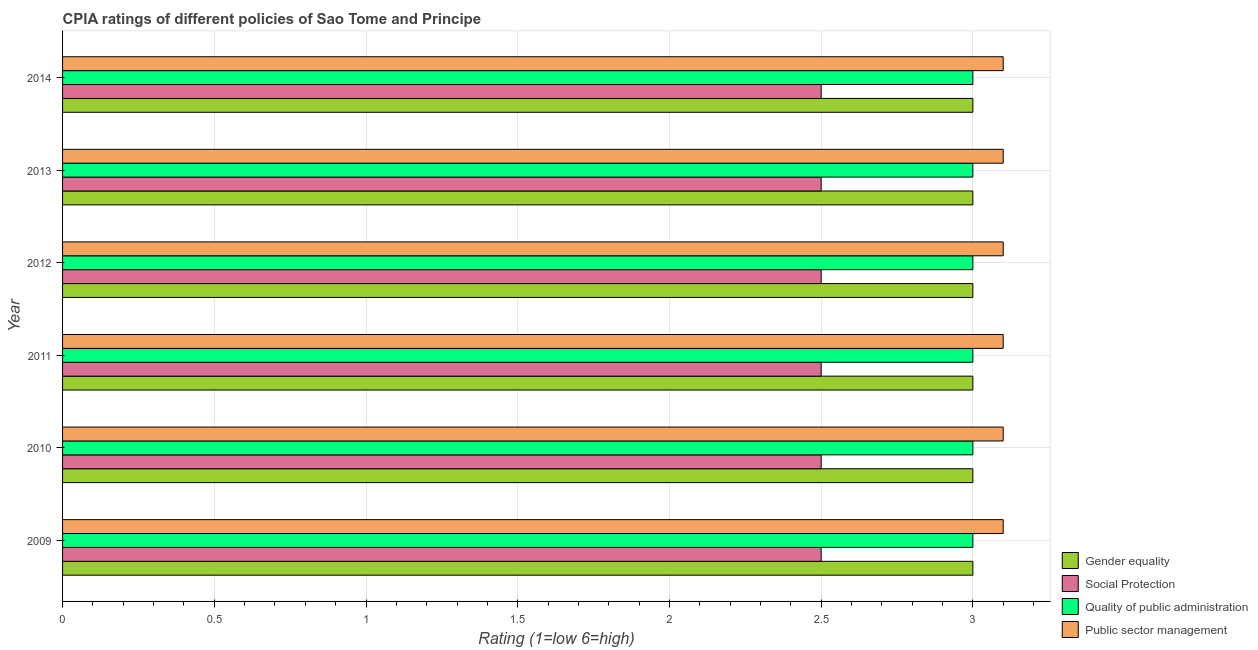How many different coloured bars are there?
Offer a terse response. 4. Are the number of bars per tick equal to the number of legend labels?
Offer a terse response. Yes. How many bars are there on the 4th tick from the top?
Keep it short and to the point. 4. How many bars are there on the 5th tick from the bottom?
Keep it short and to the point. 4. In how many cases, is the number of bars for a given year not equal to the number of legend labels?
Your response must be concise. 0. Across all years, what is the maximum cpia rating of public sector management?
Give a very brief answer. 3.1. Across all years, what is the minimum cpia rating of gender equality?
Make the answer very short. 3. In which year was the cpia rating of social protection maximum?
Your answer should be compact. 2009. In which year was the cpia rating of quality of public administration minimum?
Provide a short and direct response. 2009. What is the total cpia rating of gender equality in the graph?
Provide a short and direct response. 18. In the year 2014, what is the difference between the cpia rating of quality of public administration and cpia rating of social protection?
Make the answer very short. 0.5. Is the cpia rating of public sector management in 2010 less than that in 2013?
Offer a very short reply. No. Is the difference between the cpia rating of public sector management in 2010 and 2013 greater than the difference between the cpia rating of quality of public administration in 2010 and 2013?
Provide a short and direct response. No. Is the sum of the cpia rating of social protection in 2010 and 2012 greater than the maximum cpia rating of gender equality across all years?
Your response must be concise. Yes. Is it the case that in every year, the sum of the cpia rating of gender equality and cpia rating of quality of public administration is greater than the sum of cpia rating of public sector management and cpia rating of social protection?
Your response must be concise. No. What does the 4th bar from the top in 2011 represents?
Your response must be concise. Gender equality. What does the 2nd bar from the bottom in 2011 represents?
Keep it short and to the point. Social Protection. Is it the case that in every year, the sum of the cpia rating of gender equality and cpia rating of social protection is greater than the cpia rating of quality of public administration?
Keep it short and to the point. Yes. Are all the bars in the graph horizontal?
Give a very brief answer. Yes. Does the graph contain any zero values?
Give a very brief answer. No. Does the graph contain grids?
Provide a short and direct response. Yes. Where does the legend appear in the graph?
Make the answer very short. Bottom right. How many legend labels are there?
Your response must be concise. 4. How are the legend labels stacked?
Provide a short and direct response. Vertical. What is the title of the graph?
Your response must be concise. CPIA ratings of different policies of Sao Tome and Principe. What is the label or title of the X-axis?
Give a very brief answer. Rating (1=low 6=high). What is the label or title of the Y-axis?
Make the answer very short. Year. What is the Rating (1=low 6=high) of Gender equality in 2009?
Give a very brief answer. 3. What is the Rating (1=low 6=high) in Quality of public administration in 2009?
Provide a short and direct response. 3. What is the Rating (1=low 6=high) in Gender equality in 2010?
Your response must be concise. 3. What is the Rating (1=low 6=high) of Quality of public administration in 2010?
Your response must be concise. 3. What is the Rating (1=low 6=high) of Gender equality in 2011?
Offer a terse response. 3. What is the Rating (1=low 6=high) in Social Protection in 2011?
Make the answer very short. 2.5. What is the Rating (1=low 6=high) in Public sector management in 2011?
Your answer should be compact. 3.1. What is the Rating (1=low 6=high) of Public sector management in 2013?
Keep it short and to the point. 3.1. What is the Rating (1=low 6=high) in Gender equality in 2014?
Provide a succinct answer. 3. What is the Rating (1=low 6=high) of Social Protection in 2014?
Your answer should be compact. 2.5. Across all years, what is the maximum Rating (1=low 6=high) of Gender equality?
Your response must be concise. 3. Across all years, what is the maximum Rating (1=low 6=high) in Social Protection?
Make the answer very short. 2.5. Across all years, what is the minimum Rating (1=low 6=high) in Quality of public administration?
Provide a succinct answer. 3. What is the total Rating (1=low 6=high) in Quality of public administration in the graph?
Give a very brief answer. 18. What is the total Rating (1=low 6=high) of Public sector management in the graph?
Provide a succinct answer. 18.6. What is the difference between the Rating (1=low 6=high) in Gender equality in 2009 and that in 2010?
Provide a succinct answer. 0. What is the difference between the Rating (1=low 6=high) of Quality of public administration in 2009 and that in 2010?
Offer a very short reply. 0. What is the difference between the Rating (1=low 6=high) of Public sector management in 2009 and that in 2010?
Ensure brevity in your answer.  0. What is the difference between the Rating (1=low 6=high) in Quality of public administration in 2009 and that in 2011?
Provide a short and direct response. 0. What is the difference between the Rating (1=low 6=high) in Gender equality in 2009 and that in 2012?
Provide a short and direct response. 0. What is the difference between the Rating (1=low 6=high) of Social Protection in 2009 and that in 2012?
Offer a terse response. 0. What is the difference between the Rating (1=low 6=high) in Quality of public administration in 2009 and that in 2012?
Your answer should be compact. 0. What is the difference between the Rating (1=low 6=high) in Public sector management in 2009 and that in 2012?
Keep it short and to the point. 0. What is the difference between the Rating (1=low 6=high) of Social Protection in 2009 and that in 2013?
Your answer should be very brief. 0. What is the difference between the Rating (1=low 6=high) of Public sector management in 2009 and that in 2013?
Give a very brief answer. 0. What is the difference between the Rating (1=low 6=high) of Social Protection in 2009 and that in 2014?
Provide a succinct answer. 0. What is the difference between the Rating (1=low 6=high) in Public sector management in 2009 and that in 2014?
Make the answer very short. 0. What is the difference between the Rating (1=low 6=high) of Social Protection in 2010 and that in 2011?
Offer a terse response. 0. What is the difference between the Rating (1=low 6=high) of Quality of public administration in 2010 and that in 2011?
Make the answer very short. 0. What is the difference between the Rating (1=low 6=high) of Gender equality in 2010 and that in 2012?
Your answer should be compact. 0. What is the difference between the Rating (1=low 6=high) in Social Protection in 2010 and that in 2012?
Give a very brief answer. 0. What is the difference between the Rating (1=low 6=high) in Quality of public administration in 2010 and that in 2012?
Offer a very short reply. 0. What is the difference between the Rating (1=low 6=high) of Social Protection in 2010 and that in 2013?
Make the answer very short. 0. What is the difference between the Rating (1=low 6=high) of Quality of public administration in 2010 and that in 2013?
Your response must be concise. 0. What is the difference between the Rating (1=low 6=high) of Public sector management in 2010 and that in 2014?
Your response must be concise. 0. What is the difference between the Rating (1=low 6=high) of Social Protection in 2011 and that in 2012?
Your answer should be very brief. 0. What is the difference between the Rating (1=low 6=high) of Gender equality in 2011 and that in 2013?
Your response must be concise. 0. What is the difference between the Rating (1=low 6=high) of Social Protection in 2011 and that in 2013?
Your answer should be compact. 0. What is the difference between the Rating (1=low 6=high) of Social Protection in 2011 and that in 2014?
Offer a terse response. 0. What is the difference between the Rating (1=low 6=high) of Public sector management in 2012 and that in 2013?
Give a very brief answer. 0. What is the difference between the Rating (1=low 6=high) of Public sector management in 2012 and that in 2014?
Offer a very short reply. 0. What is the difference between the Rating (1=low 6=high) in Gender equality in 2013 and that in 2014?
Ensure brevity in your answer.  0. What is the difference between the Rating (1=low 6=high) of Quality of public administration in 2013 and that in 2014?
Offer a terse response. 0. What is the difference between the Rating (1=low 6=high) in Gender equality in 2009 and the Rating (1=low 6=high) in Social Protection in 2010?
Provide a short and direct response. 0.5. What is the difference between the Rating (1=low 6=high) in Gender equality in 2009 and the Rating (1=low 6=high) in Quality of public administration in 2010?
Offer a terse response. 0. What is the difference between the Rating (1=low 6=high) in Social Protection in 2009 and the Rating (1=low 6=high) in Quality of public administration in 2010?
Offer a very short reply. -0.5. What is the difference between the Rating (1=low 6=high) of Social Protection in 2009 and the Rating (1=low 6=high) of Public sector management in 2010?
Provide a succinct answer. -0.6. What is the difference between the Rating (1=low 6=high) in Quality of public administration in 2009 and the Rating (1=low 6=high) in Public sector management in 2010?
Offer a very short reply. -0.1. What is the difference between the Rating (1=low 6=high) of Social Protection in 2009 and the Rating (1=low 6=high) of Quality of public administration in 2011?
Offer a very short reply. -0.5. What is the difference between the Rating (1=low 6=high) in Social Protection in 2009 and the Rating (1=low 6=high) in Public sector management in 2011?
Your answer should be very brief. -0.6. What is the difference between the Rating (1=low 6=high) of Gender equality in 2009 and the Rating (1=low 6=high) of Social Protection in 2012?
Offer a terse response. 0.5. What is the difference between the Rating (1=low 6=high) in Social Protection in 2009 and the Rating (1=low 6=high) in Quality of public administration in 2012?
Make the answer very short. -0.5. What is the difference between the Rating (1=low 6=high) of Quality of public administration in 2009 and the Rating (1=low 6=high) of Public sector management in 2012?
Make the answer very short. -0.1. What is the difference between the Rating (1=low 6=high) of Gender equality in 2009 and the Rating (1=low 6=high) of Social Protection in 2013?
Provide a succinct answer. 0.5. What is the difference between the Rating (1=low 6=high) of Social Protection in 2009 and the Rating (1=low 6=high) of Quality of public administration in 2013?
Your response must be concise. -0.5. What is the difference between the Rating (1=low 6=high) in Social Protection in 2009 and the Rating (1=low 6=high) in Public sector management in 2013?
Ensure brevity in your answer.  -0.6. What is the difference between the Rating (1=low 6=high) in Gender equality in 2009 and the Rating (1=low 6=high) in Social Protection in 2014?
Keep it short and to the point. 0.5. What is the difference between the Rating (1=low 6=high) in Gender equality in 2009 and the Rating (1=low 6=high) in Quality of public administration in 2014?
Provide a short and direct response. 0. What is the difference between the Rating (1=low 6=high) of Quality of public administration in 2009 and the Rating (1=low 6=high) of Public sector management in 2014?
Offer a very short reply. -0.1. What is the difference between the Rating (1=low 6=high) in Gender equality in 2010 and the Rating (1=low 6=high) in Quality of public administration in 2011?
Provide a succinct answer. 0. What is the difference between the Rating (1=low 6=high) of Gender equality in 2010 and the Rating (1=low 6=high) of Quality of public administration in 2012?
Offer a very short reply. 0. What is the difference between the Rating (1=low 6=high) of Social Protection in 2010 and the Rating (1=low 6=high) of Quality of public administration in 2012?
Ensure brevity in your answer.  -0.5. What is the difference between the Rating (1=low 6=high) of Social Protection in 2010 and the Rating (1=low 6=high) of Quality of public administration in 2013?
Your response must be concise. -0.5. What is the difference between the Rating (1=low 6=high) of Social Protection in 2010 and the Rating (1=low 6=high) of Public sector management in 2013?
Ensure brevity in your answer.  -0.6. What is the difference between the Rating (1=low 6=high) in Quality of public administration in 2010 and the Rating (1=low 6=high) in Public sector management in 2013?
Your response must be concise. -0.1. What is the difference between the Rating (1=low 6=high) in Gender equality in 2010 and the Rating (1=low 6=high) in Social Protection in 2014?
Your response must be concise. 0.5. What is the difference between the Rating (1=low 6=high) in Gender equality in 2010 and the Rating (1=low 6=high) in Quality of public administration in 2014?
Your answer should be very brief. 0. What is the difference between the Rating (1=low 6=high) of Social Protection in 2010 and the Rating (1=low 6=high) of Quality of public administration in 2014?
Provide a short and direct response. -0.5. What is the difference between the Rating (1=low 6=high) in Social Protection in 2010 and the Rating (1=low 6=high) in Public sector management in 2014?
Provide a succinct answer. -0.6. What is the difference between the Rating (1=low 6=high) of Gender equality in 2011 and the Rating (1=low 6=high) of Quality of public administration in 2012?
Your response must be concise. 0. What is the difference between the Rating (1=low 6=high) of Social Protection in 2011 and the Rating (1=low 6=high) of Public sector management in 2012?
Make the answer very short. -0.6. What is the difference between the Rating (1=low 6=high) in Quality of public administration in 2011 and the Rating (1=low 6=high) in Public sector management in 2012?
Provide a short and direct response. -0.1. What is the difference between the Rating (1=low 6=high) of Gender equality in 2011 and the Rating (1=low 6=high) of Quality of public administration in 2013?
Give a very brief answer. 0. What is the difference between the Rating (1=low 6=high) of Gender equality in 2011 and the Rating (1=low 6=high) of Public sector management in 2013?
Keep it short and to the point. -0.1. What is the difference between the Rating (1=low 6=high) of Social Protection in 2011 and the Rating (1=low 6=high) of Quality of public administration in 2013?
Offer a very short reply. -0.5. What is the difference between the Rating (1=low 6=high) in Social Protection in 2011 and the Rating (1=low 6=high) in Public sector management in 2013?
Provide a succinct answer. -0.6. What is the difference between the Rating (1=low 6=high) in Quality of public administration in 2011 and the Rating (1=low 6=high) in Public sector management in 2013?
Keep it short and to the point. -0.1. What is the difference between the Rating (1=low 6=high) in Gender equality in 2011 and the Rating (1=low 6=high) in Social Protection in 2014?
Your answer should be very brief. 0.5. What is the difference between the Rating (1=low 6=high) in Gender equality in 2012 and the Rating (1=low 6=high) in Public sector management in 2013?
Provide a short and direct response. -0.1. What is the difference between the Rating (1=low 6=high) of Social Protection in 2012 and the Rating (1=low 6=high) of Quality of public administration in 2013?
Offer a terse response. -0.5. What is the difference between the Rating (1=low 6=high) in Social Protection in 2012 and the Rating (1=low 6=high) in Public sector management in 2013?
Provide a succinct answer. -0.6. What is the difference between the Rating (1=low 6=high) in Quality of public administration in 2012 and the Rating (1=low 6=high) in Public sector management in 2013?
Keep it short and to the point. -0.1. What is the difference between the Rating (1=low 6=high) of Gender equality in 2012 and the Rating (1=low 6=high) of Social Protection in 2014?
Give a very brief answer. 0.5. What is the difference between the Rating (1=low 6=high) in Gender equality in 2012 and the Rating (1=low 6=high) in Quality of public administration in 2014?
Keep it short and to the point. 0. What is the difference between the Rating (1=low 6=high) of Gender equality in 2012 and the Rating (1=low 6=high) of Public sector management in 2014?
Keep it short and to the point. -0.1. What is the difference between the Rating (1=low 6=high) of Gender equality in 2013 and the Rating (1=low 6=high) of Social Protection in 2014?
Offer a terse response. 0.5. What is the difference between the Rating (1=low 6=high) of Gender equality in 2013 and the Rating (1=low 6=high) of Quality of public administration in 2014?
Provide a short and direct response. 0. What is the difference between the Rating (1=low 6=high) in Social Protection in 2013 and the Rating (1=low 6=high) in Public sector management in 2014?
Provide a succinct answer. -0.6. What is the average Rating (1=low 6=high) of Quality of public administration per year?
Offer a very short reply. 3. In the year 2009, what is the difference between the Rating (1=low 6=high) of Gender equality and Rating (1=low 6=high) of Social Protection?
Provide a short and direct response. 0.5. In the year 2009, what is the difference between the Rating (1=low 6=high) of Gender equality and Rating (1=low 6=high) of Public sector management?
Ensure brevity in your answer.  -0.1. In the year 2010, what is the difference between the Rating (1=low 6=high) in Gender equality and Rating (1=low 6=high) in Social Protection?
Give a very brief answer. 0.5. In the year 2010, what is the difference between the Rating (1=low 6=high) of Gender equality and Rating (1=low 6=high) of Quality of public administration?
Provide a succinct answer. 0. In the year 2010, what is the difference between the Rating (1=low 6=high) of Gender equality and Rating (1=low 6=high) of Public sector management?
Your response must be concise. -0.1. In the year 2010, what is the difference between the Rating (1=low 6=high) of Social Protection and Rating (1=low 6=high) of Quality of public administration?
Keep it short and to the point. -0.5. In the year 2010, what is the difference between the Rating (1=low 6=high) of Quality of public administration and Rating (1=low 6=high) of Public sector management?
Keep it short and to the point. -0.1. In the year 2011, what is the difference between the Rating (1=low 6=high) of Gender equality and Rating (1=low 6=high) of Social Protection?
Your response must be concise. 0.5. In the year 2011, what is the difference between the Rating (1=low 6=high) of Gender equality and Rating (1=low 6=high) of Public sector management?
Offer a terse response. -0.1. In the year 2011, what is the difference between the Rating (1=low 6=high) of Social Protection and Rating (1=low 6=high) of Quality of public administration?
Provide a succinct answer. -0.5. In the year 2012, what is the difference between the Rating (1=low 6=high) of Gender equality and Rating (1=low 6=high) of Social Protection?
Keep it short and to the point. 0.5. In the year 2012, what is the difference between the Rating (1=low 6=high) of Gender equality and Rating (1=low 6=high) of Quality of public administration?
Provide a short and direct response. 0. In the year 2012, what is the difference between the Rating (1=low 6=high) of Gender equality and Rating (1=low 6=high) of Public sector management?
Keep it short and to the point. -0.1. In the year 2012, what is the difference between the Rating (1=low 6=high) in Social Protection and Rating (1=low 6=high) in Quality of public administration?
Give a very brief answer. -0.5. In the year 2012, what is the difference between the Rating (1=low 6=high) in Social Protection and Rating (1=low 6=high) in Public sector management?
Offer a terse response. -0.6. In the year 2013, what is the difference between the Rating (1=low 6=high) of Gender equality and Rating (1=low 6=high) of Social Protection?
Provide a short and direct response. 0.5. In the year 2013, what is the difference between the Rating (1=low 6=high) in Gender equality and Rating (1=low 6=high) in Quality of public administration?
Provide a succinct answer. 0. In the year 2013, what is the difference between the Rating (1=low 6=high) of Gender equality and Rating (1=low 6=high) of Public sector management?
Offer a very short reply. -0.1. In the year 2014, what is the difference between the Rating (1=low 6=high) of Gender equality and Rating (1=low 6=high) of Quality of public administration?
Make the answer very short. 0. In the year 2014, what is the difference between the Rating (1=low 6=high) of Gender equality and Rating (1=low 6=high) of Public sector management?
Your answer should be compact. -0.1. In the year 2014, what is the difference between the Rating (1=low 6=high) in Social Protection and Rating (1=low 6=high) in Quality of public administration?
Provide a succinct answer. -0.5. What is the ratio of the Rating (1=low 6=high) in Quality of public administration in 2009 to that in 2010?
Give a very brief answer. 1. What is the ratio of the Rating (1=low 6=high) in Quality of public administration in 2009 to that in 2012?
Offer a terse response. 1. What is the ratio of the Rating (1=low 6=high) in Gender equality in 2009 to that in 2013?
Provide a succinct answer. 1. What is the ratio of the Rating (1=low 6=high) of Social Protection in 2009 to that in 2014?
Your response must be concise. 1. What is the ratio of the Rating (1=low 6=high) of Public sector management in 2010 to that in 2011?
Your response must be concise. 1. What is the ratio of the Rating (1=low 6=high) of Gender equality in 2010 to that in 2012?
Keep it short and to the point. 1. What is the ratio of the Rating (1=low 6=high) of Public sector management in 2010 to that in 2012?
Provide a short and direct response. 1. What is the ratio of the Rating (1=low 6=high) of Social Protection in 2010 to that in 2013?
Your answer should be very brief. 1. What is the ratio of the Rating (1=low 6=high) in Quality of public administration in 2010 to that in 2013?
Your answer should be compact. 1. What is the ratio of the Rating (1=low 6=high) of Public sector management in 2010 to that in 2013?
Your response must be concise. 1. What is the ratio of the Rating (1=low 6=high) in Gender equality in 2010 to that in 2014?
Your answer should be very brief. 1. What is the ratio of the Rating (1=low 6=high) in Social Protection in 2010 to that in 2014?
Your answer should be very brief. 1. What is the ratio of the Rating (1=low 6=high) in Public sector management in 2010 to that in 2014?
Your answer should be very brief. 1. What is the ratio of the Rating (1=low 6=high) in Public sector management in 2011 to that in 2012?
Provide a short and direct response. 1. What is the ratio of the Rating (1=low 6=high) of Quality of public administration in 2011 to that in 2013?
Provide a short and direct response. 1. What is the ratio of the Rating (1=low 6=high) in Public sector management in 2011 to that in 2013?
Offer a very short reply. 1. What is the ratio of the Rating (1=low 6=high) of Social Protection in 2011 to that in 2014?
Give a very brief answer. 1. What is the ratio of the Rating (1=low 6=high) in Quality of public administration in 2011 to that in 2014?
Your response must be concise. 1. What is the ratio of the Rating (1=low 6=high) of Public sector management in 2011 to that in 2014?
Provide a succinct answer. 1. What is the ratio of the Rating (1=low 6=high) in Gender equality in 2012 to that in 2013?
Your response must be concise. 1. What is the ratio of the Rating (1=low 6=high) in Quality of public administration in 2012 to that in 2013?
Provide a succinct answer. 1. What is the ratio of the Rating (1=low 6=high) of Gender equality in 2012 to that in 2014?
Give a very brief answer. 1. What is the ratio of the Rating (1=low 6=high) in Public sector management in 2012 to that in 2014?
Give a very brief answer. 1. What is the ratio of the Rating (1=low 6=high) in Social Protection in 2013 to that in 2014?
Keep it short and to the point. 1. What is the ratio of the Rating (1=low 6=high) of Quality of public administration in 2013 to that in 2014?
Your answer should be compact. 1. What is the difference between the highest and the second highest Rating (1=low 6=high) of Gender equality?
Offer a terse response. 0. What is the difference between the highest and the second highest Rating (1=low 6=high) in Social Protection?
Offer a terse response. 0. What is the difference between the highest and the second highest Rating (1=low 6=high) in Public sector management?
Offer a terse response. 0. What is the difference between the highest and the lowest Rating (1=low 6=high) of Social Protection?
Offer a very short reply. 0. 